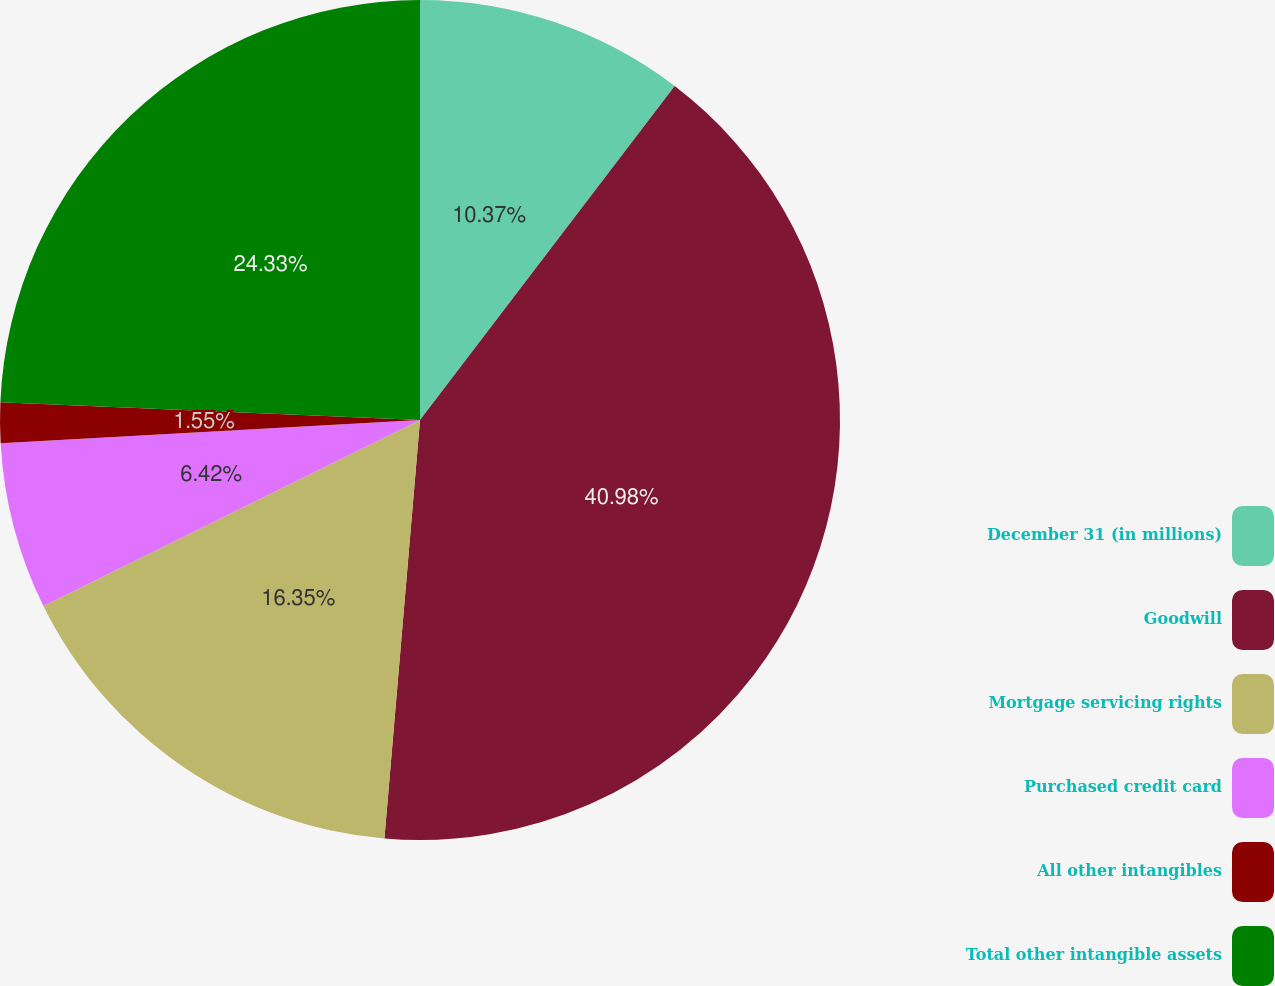<chart> <loc_0><loc_0><loc_500><loc_500><pie_chart><fcel>December 31 (in millions)<fcel>Goodwill<fcel>Mortgage servicing rights<fcel>Purchased credit card<fcel>All other intangibles<fcel>Total other intangible assets<nl><fcel>10.37%<fcel>40.98%<fcel>16.35%<fcel>6.42%<fcel>1.55%<fcel>24.33%<nl></chart> 